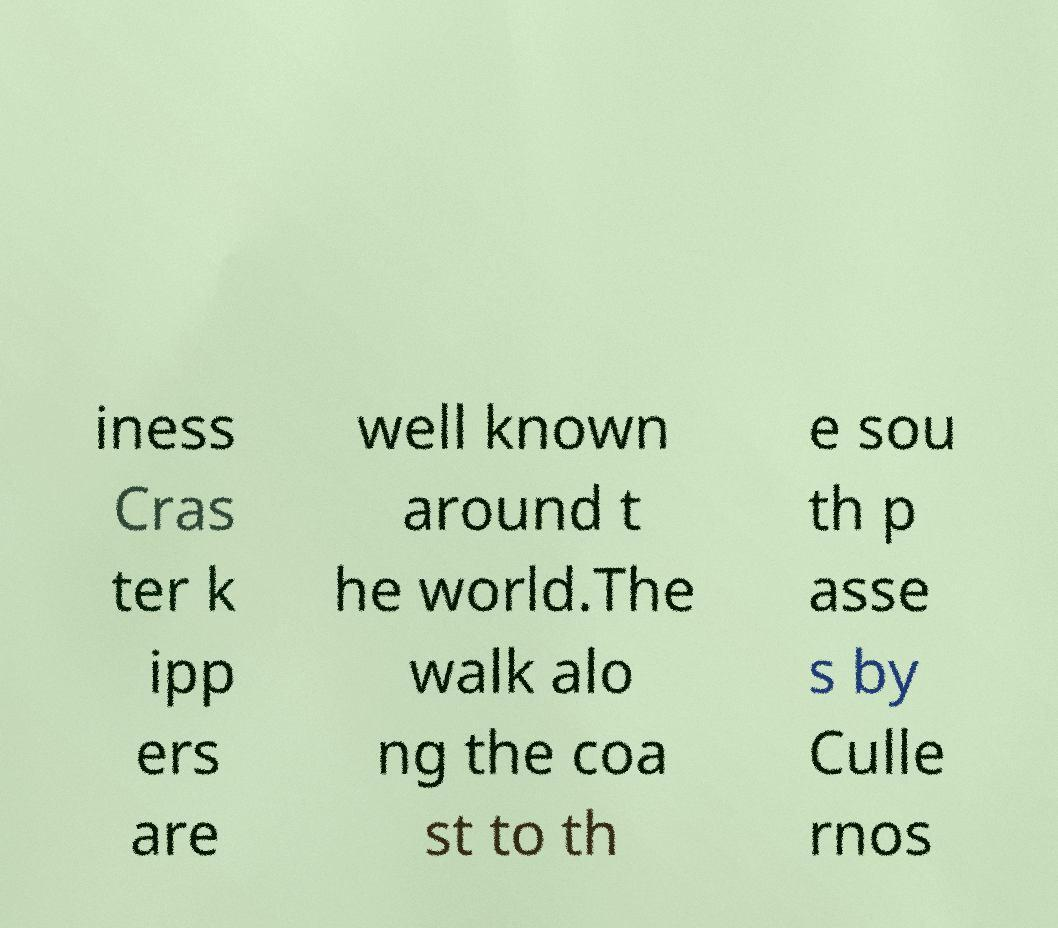Please identify and transcribe the text found in this image. iness Cras ter k ipp ers are well known around t he world.The walk alo ng the coa st to th e sou th p asse s by Culle rnos 